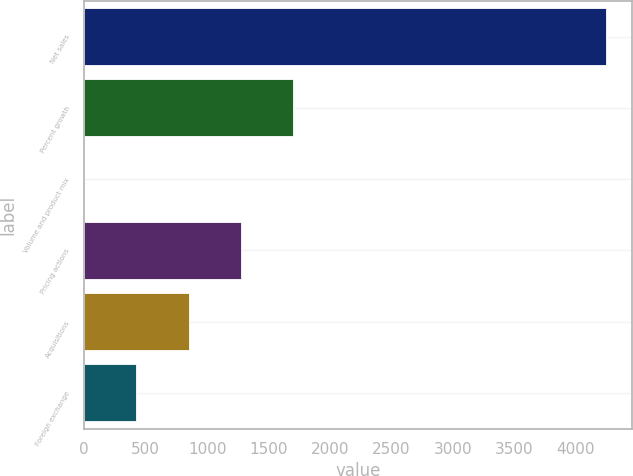Convert chart to OTSL. <chart><loc_0><loc_0><loc_500><loc_500><bar_chart><fcel>Net sales<fcel>Percent growth<fcel>Volume and product mix<fcel>Pricing actions<fcel>Acquisitions<fcel>Foreign exchange<nl><fcel>4243.2<fcel>1697.4<fcel>0.2<fcel>1273.1<fcel>848.8<fcel>424.5<nl></chart> 